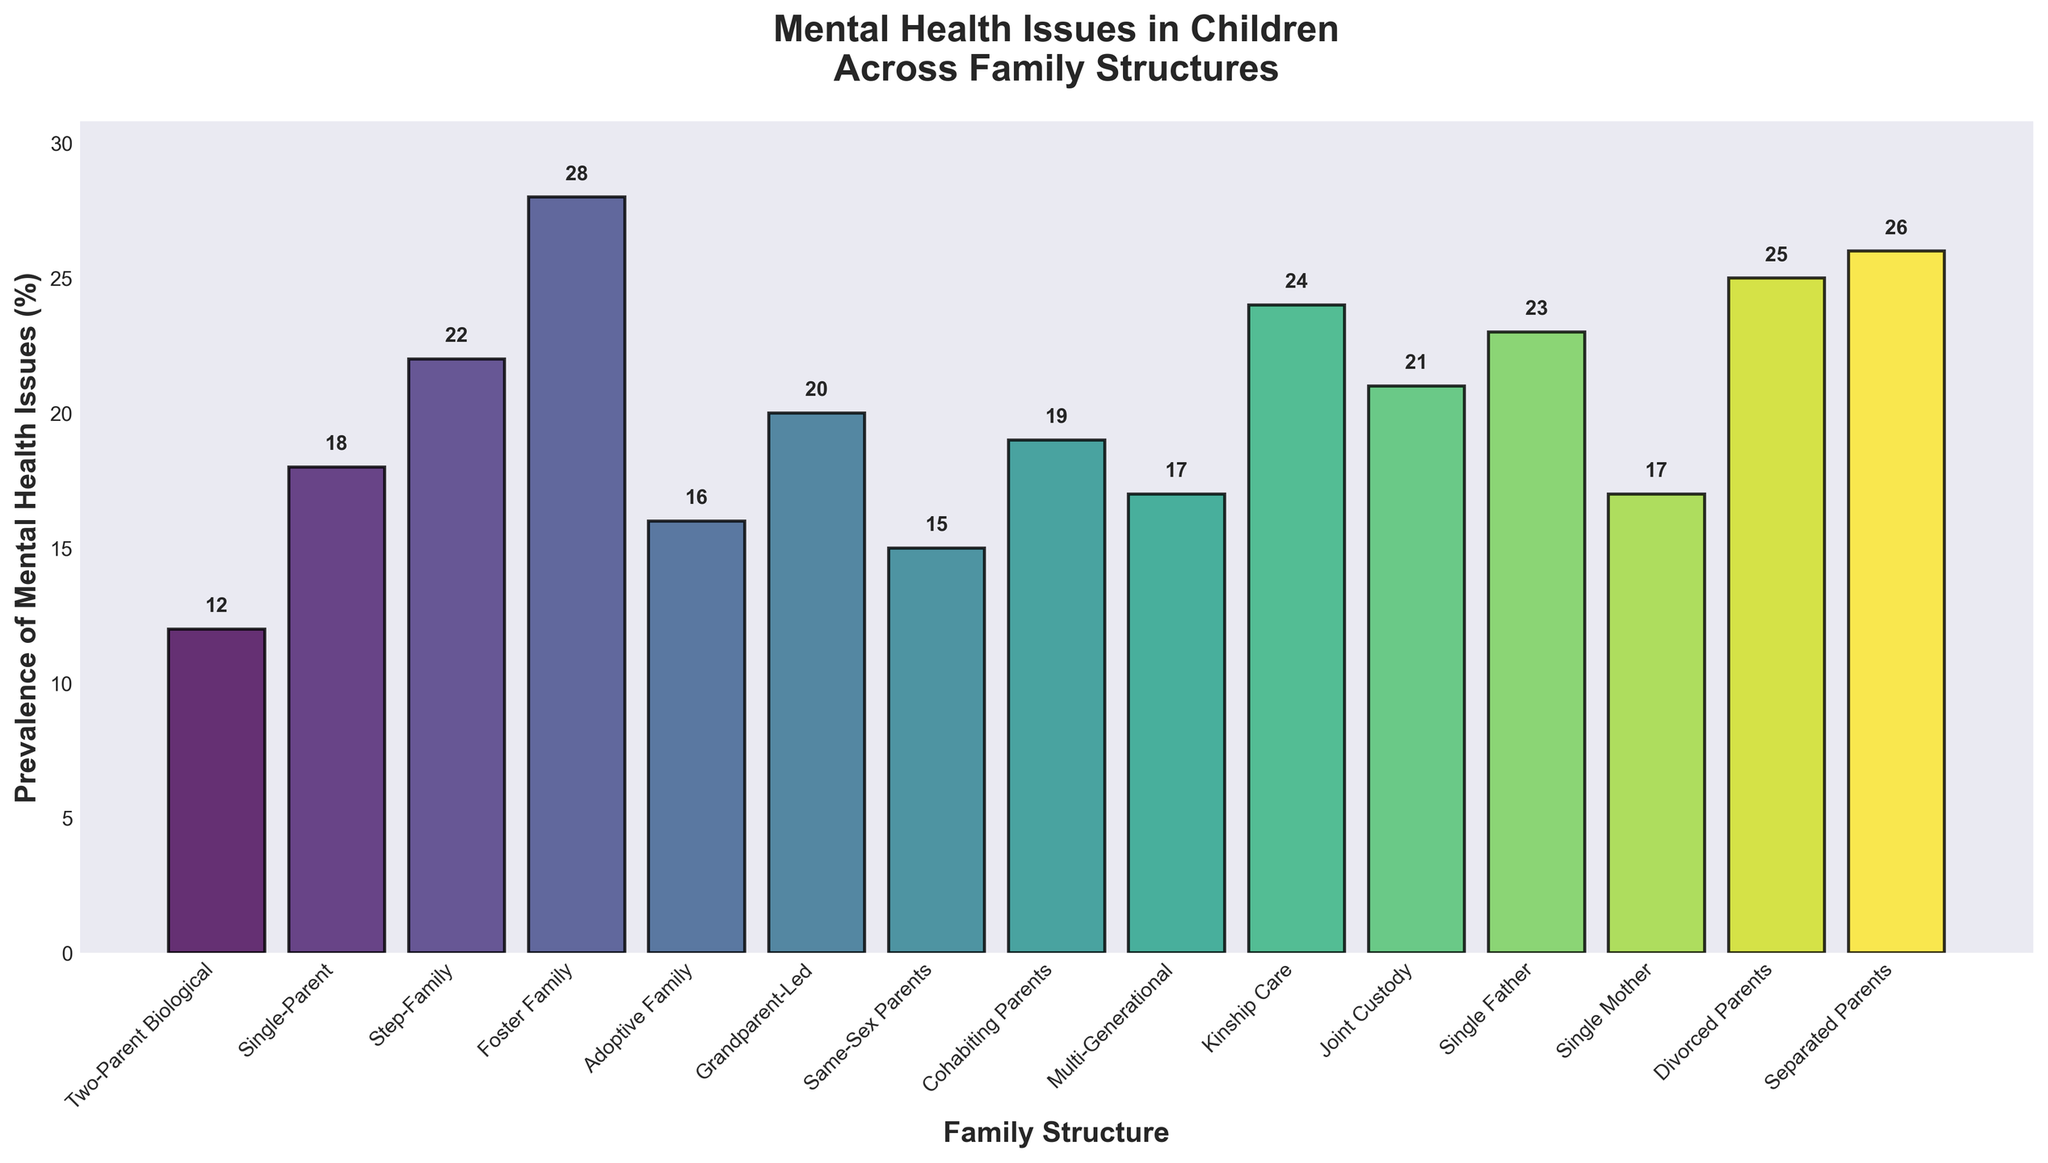Which family structure has the highest prevalence of mental health issues? To determine which family structure has the highest prevalence, examine the heights of the bars. The tallest bar represents "Foster Family" with a value of 28%.
Answer: Foster Family Which family structure has the lowest prevalence of mental health issues? To find the lowest prevalence, look for the shortest bar in the chart. The shortest bar belongs to the "Two-Parent Biological" structure, with a value of 12%.
Answer: Two-Parent Biological How much higher is the prevalence of mental health issues in children from Foster Families compared to children from Single-Parent families? First, identify the prevalence values for both Foster Families (28%) and Single-Parent families (18%). Then subtract the lower value from the higher value: 28% - 18% = 10%.
Answer: 10% What is the average prevalence of mental health issues across all family structures? Sum the prevalence values for all the family structures and then divide by the number of structures. The sum is (12 + 18 + 22 + 28 + 16 + 20 + 15 + 19 + 17 + 24 + 21 + 23 + 17 + 25 + 26) = 303. There are 15 family structures. The average is 303 / 15 = 20.2%.
Answer: 20.2% Which family structures have a prevalence rate below the overall average? First, calculate the average prevalence, which is 20.2%. Then, list all family structures with prevalence rates below this average: Two-Parent Biological (12%), Single-Parent (18%), Adoptive Family (16%), Same-Sex Parents (15%), Multi-Generational (17%), and Single Mother (17%).
Answer: Two-Parent Biological, Single-Parent, Adoptive Family, Same-Sex Parents, Multi-Generational, Single Mother By how much does the prevalence rate for Single Mothers exceed that for Two-Parent Biological families? Identify the prevalence values for Single Mothers (17%) and Two-Parent Biological families (12%). Subtract the lower value from the higher value: 17% - 12% = 5%.
Answer: 5% Which family structure has a prevalence closest to, but below, the prevalence rate of Separated Parents? First, find the prevalence rate of Separated Parents, which is 26%. Look for the highest rate below 26%: Divorced Parents with a prevalence rate of 25%.
Answer: Divorced Parents What is the total prevalence of mental health issues for children in Step-Families and Kinship Care? Identify the prevalence values for Step-Families (22%) and Kinship Care (24%). Add the two values together: 22% + 24% = 46%.
Answer: 46% Are children in Grandparent-Led families more likely to have mental health issues than those in Single-Parent families? Compare the prevalence values for Grandparent-Led families (20%) and Single-Parent families (18%). Since 20% is greater than 18%, children in Grandparent-Led families are more likely to have mental health issues.
Answer: Yes How do the prevalence rates for children in Joint Custody and Step-Families compare? Compare the prevalence values for Joint Custody (21%) and Step-Families (22%). The prevalence in Step-Families is 1% higher than that in Joint Custody families.
Answer: Step-Families have a slightly higher prevalence 